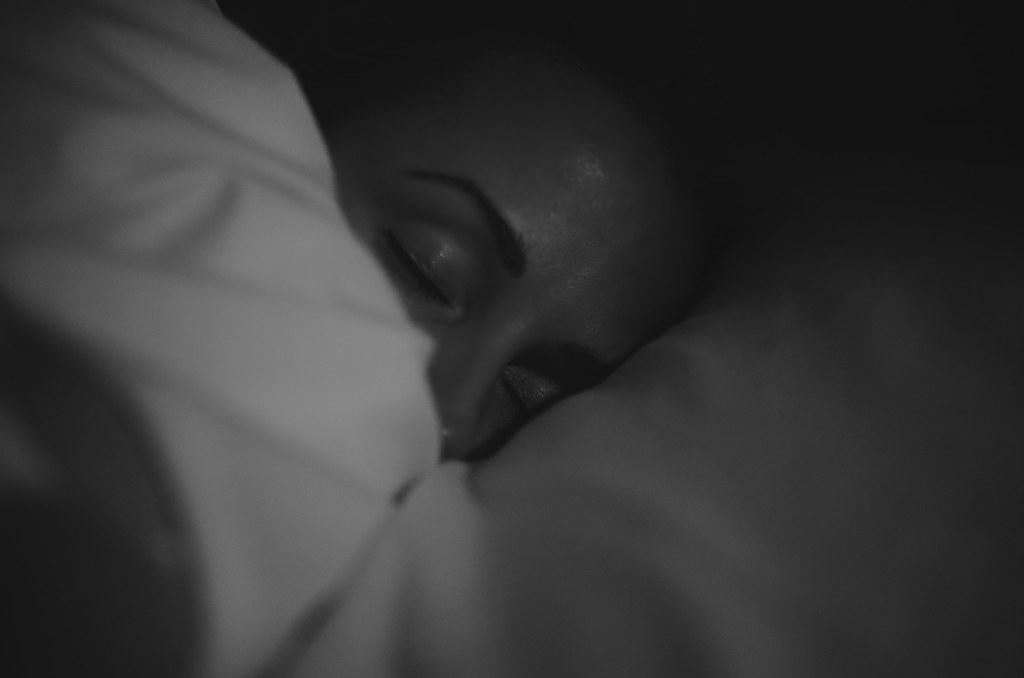What is the color scheme of the image? The picture is black and white. What object can be seen in the image? There is a cloth in the image. Are there any people in the image? Yes, there is a person in the image. What type of square object is being held by the person in the image? There is no square object being held by the person in the image. Can you tell me how many apples are on the cloth in the image? There are no apples present in the image. 